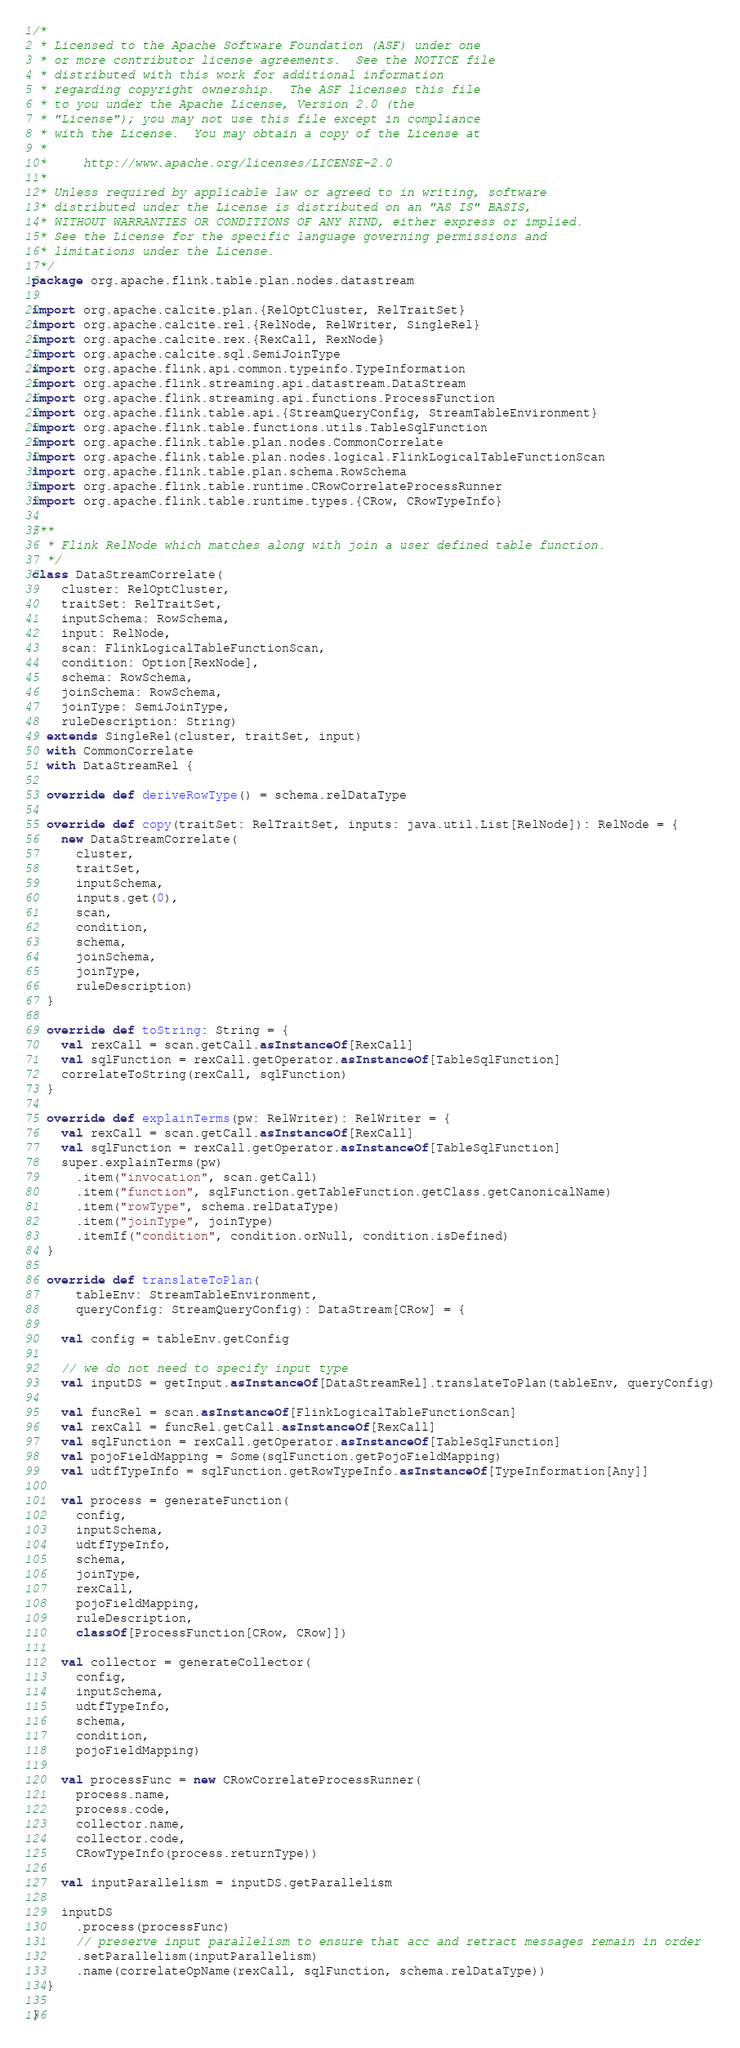<code> <loc_0><loc_0><loc_500><loc_500><_Scala_>/*
 * Licensed to the Apache Software Foundation (ASF) under one
 * or more contributor license agreements.  See the NOTICE file
 * distributed with this work for additional information
 * regarding copyright ownership.  The ASF licenses this file
 * to you under the Apache License, Version 2.0 (the
 * "License"); you may not use this file except in compliance
 * with the License.  You may obtain a copy of the License at
 *
 *     http://www.apache.org/licenses/LICENSE-2.0
 *
 * Unless required by applicable law or agreed to in writing, software
 * distributed under the License is distributed on an "AS IS" BASIS,
 * WITHOUT WARRANTIES OR CONDITIONS OF ANY KIND, either express or implied.
 * See the License for the specific language governing permissions and
 * limitations under the License.
 */
package org.apache.flink.table.plan.nodes.datastream

import org.apache.calcite.plan.{RelOptCluster, RelTraitSet}
import org.apache.calcite.rel.{RelNode, RelWriter, SingleRel}
import org.apache.calcite.rex.{RexCall, RexNode}
import org.apache.calcite.sql.SemiJoinType
import org.apache.flink.api.common.typeinfo.TypeInformation
import org.apache.flink.streaming.api.datastream.DataStream
import org.apache.flink.streaming.api.functions.ProcessFunction
import org.apache.flink.table.api.{StreamQueryConfig, StreamTableEnvironment}
import org.apache.flink.table.functions.utils.TableSqlFunction
import org.apache.flink.table.plan.nodes.CommonCorrelate
import org.apache.flink.table.plan.nodes.logical.FlinkLogicalTableFunctionScan
import org.apache.flink.table.plan.schema.RowSchema
import org.apache.flink.table.runtime.CRowCorrelateProcessRunner
import org.apache.flink.table.runtime.types.{CRow, CRowTypeInfo}

/**
  * Flink RelNode which matches along with join a user defined table function.
  */
class DataStreamCorrelate(
    cluster: RelOptCluster,
    traitSet: RelTraitSet,
    inputSchema: RowSchema,
    input: RelNode,
    scan: FlinkLogicalTableFunctionScan,
    condition: Option[RexNode],
    schema: RowSchema,
    joinSchema: RowSchema,
    joinType: SemiJoinType,
    ruleDescription: String)
  extends SingleRel(cluster, traitSet, input)
  with CommonCorrelate
  with DataStreamRel {

  override def deriveRowType() = schema.relDataType

  override def copy(traitSet: RelTraitSet, inputs: java.util.List[RelNode]): RelNode = {
    new DataStreamCorrelate(
      cluster,
      traitSet,
      inputSchema,
      inputs.get(0),
      scan,
      condition,
      schema,
      joinSchema,
      joinType,
      ruleDescription)
  }

  override def toString: String = {
    val rexCall = scan.getCall.asInstanceOf[RexCall]
    val sqlFunction = rexCall.getOperator.asInstanceOf[TableSqlFunction]
    correlateToString(rexCall, sqlFunction)
  }

  override def explainTerms(pw: RelWriter): RelWriter = {
    val rexCall = scan.getCall.asInstanceOf[RexCall]
    val sqlFunction = rexCall.getOperator.asInstanceOf[TableSqlFunction]
    super.explainTerms(pw)
      .item("invocation", scan.getCall)
      .item("function", sqlFunction.getTableFunction.getClass.getCanonicalName)
      .item("rowType", schema.relDataType)
      .item("joinType", joinType)
      .itemIf("condition", condition.orNull, condition.isDefined)
  }

  override def translateToPlan(
      tableEnv: StreamTableEnvironment,
      queryConfig: StreamQueryConfig): DataStream[CRow] = {

    val config = tableEnv.getConfig

    // we do not need to specify input type
    val inputDS = getInput.asInstanceOf[DataStreamRel].translateToPlan(tableEnv, queryConfig)

    val funcRel = scan.asInstanceOf[FlinkLogicalTableFunctionScan]
    val rexCall = funcRel.getCall.asInstanceOf[RexCall]
    val sqlFunction = rexCall.getOperator.asInstanceOf[TableSqlFunction]
    val pojoFieldMapping = Some(sqlFunction.getPojoFieldMapping)
    val udtfTypeInfo = sqlFunction.getRowTypeInfo.asInstanceOf[TypeInformation[Any]]

    val process = generateFunction(
      config,
      inputSchema,
      udtfTypeInfo,
      schema,
      joinType,
      rexCall,
      pojoFieldMapping,
      ruleDescription,
      classOf[ProcessFunction[CRow, CRow]])

    val collector = generateCollector(
      config,
      inputSchema,
      udtfTypeInfo,
      schema,
      condition,
      pojoFieldMapping)

    val processFunc = new CRowCorrelateProcessRunner(
      process.name,
      process.code,
      collector.name,
      collector.code,
      CRowTypeInfo(process.returnType))

    val inputParallelism = inputDS.getParallelism

    inputDS
      .process(processFunc)
      // preserve input parallelism to ensure that acc and retract messages remain in order
      .setParallelism(inputParallelism)
      .name(correlateOpName(rexCall, sqlFunction, schema.relDataType))
  }

}
</code> 